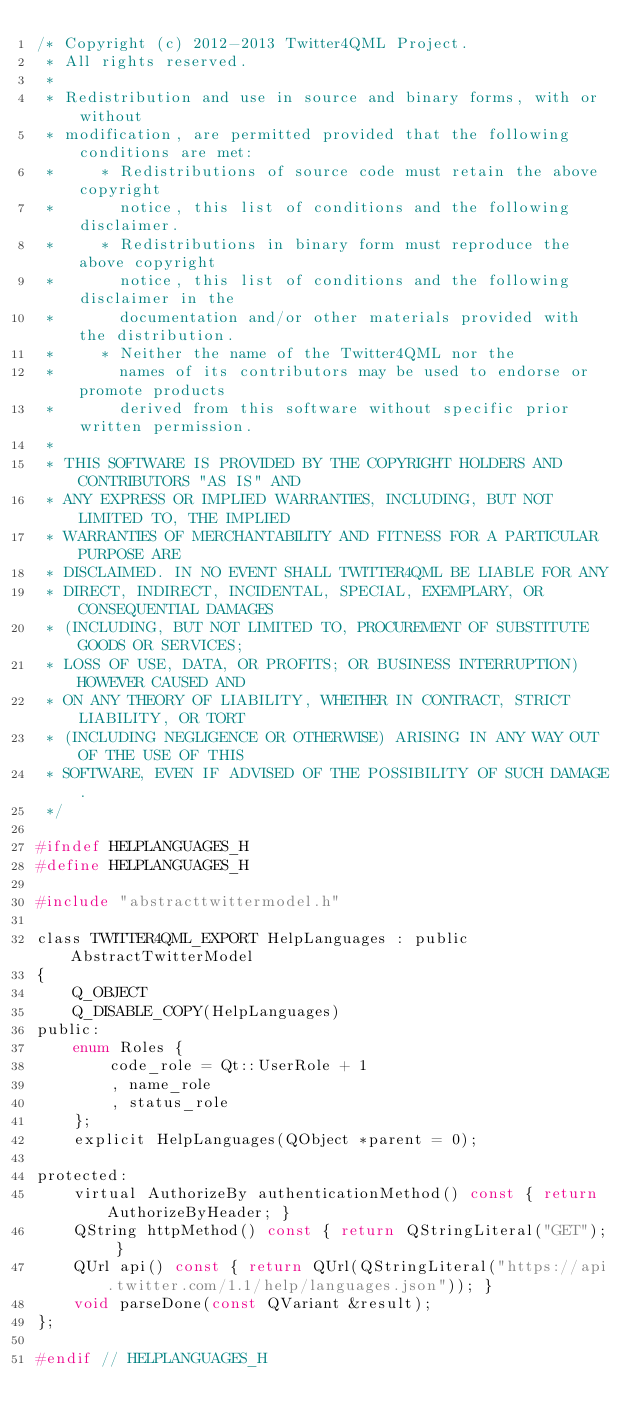<code> <loc_0><loc_0><loc_500><loc_500><_C_>/* Copyright (c) 2012-2013 Twitter4QML Project.
 * All rights reserved.
 * 
 * Redistribution and use in source and binary forms, with or without
 * modification, are permitted provided that the following conditions are met:
 *     * Redistributions of source code must retain the above copyright
 *       notice, this list of conditions and the following disclaimer.
 *     * Redistributions in binary form must reproduce the above copyright
 *       notice, this list of conditions and the following disclaimer in the
 *       documentation and/or other materials provided with the distribution.
 *     * Neither the name of the Twitter4QML nor the
 *       names of its contributors may be used to endorse or promote products
 *       derived from this software without specific prior written permission.
 * 
 * THIS SOFTWARE IS PROVIDED BY THE COPYRIGHT HOLDERS AND CONTRIBUTORS "AS IS" AND
 * ANY EXPRESS OR IMPLIED WARRANTIES, INCLUDING, BUT NOT LIMITED TO, THE IMPLIED
 * WARRANTIES OF MERCHANTABILITY AND FITNESS FOR A PARTICULAR PURPOSE ARE
 * DISCLAIMED. IN NO EVENT SHALL TWITTER4QML BE LIABLE FOR ANY
 * DIRECT, INDIRECT, INCIDENTAL, SPECIAL, EXEMPLARY, OR CONSEQUENTIAL DAMAGES
 * (INCLUDING, BUT NOT LIMITED TO, PROCUREMENT OF SUBSTITUTE GOODS OR SERVICES;
 * LOSS OF USE, DATA, OR PROFITS; OR BUSINESS INTERRUPTION) HOWEVER CAUSED AND
 * ON ANY THEORY OF LIABILITY, WHETHER IN CONTRACT, STRICT LIABILITY, OR TORT
 * (INCLUDING NEGLIGENCE OR OTHERWISE) ARISING IN ANY WAY OUT OF THE USE OF THIS
 * SOFTWARE, EVEN IF ADVISED OF THE POSSIBILITY OF SUCH DAMAGE.
 */

#ifndef HELPLANGUAGES_H
#define HELPLANGUAGES_H

#include "abstracttwittermodel.h"

class TWITTER4QML_EXPORT HelpLanguages : public AbstractTwitterModel
{
    Q_OBJECT
    Q_DISABLE_COPY(HelpLanguages)
public:
    enum Roles {
        code_role = Qt::UserRole + 1
        , name_role
        , status_role
    };
    explicit HelpLanguages(QObject *parent = 0);

protected:
    virtual AuthorizeBy authenticationMethod() const { return AuthorizeByHeader; }
    QString httpMethod() const { return QStringLiteral("GET"); }
    QUrl api() const { return QUrl(QStringLiteral("https://api.twitter.com/1.1/help/languages.json")); }
    void parseDone(const QVariant &result);
};

#endif // HELPLANGUAGES_H
</code> 